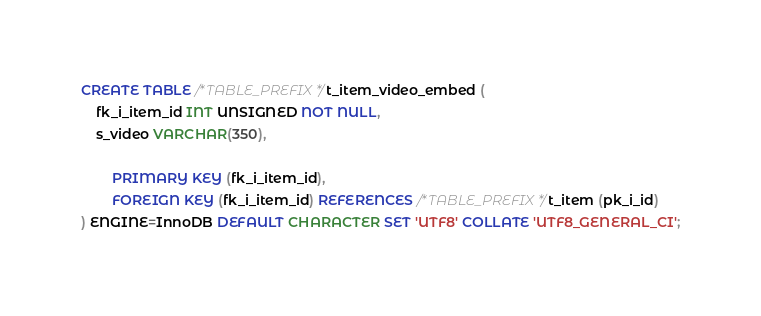<code> <loc_0><loc_0><loc_500><loc_500><_SQL_>CREATE TABLE /*TABLE_PREFIX*/t_item_video_embed (
    fk_i_item_id INT UNSIGNED NOT NULL,
    s_video VARCHAR(350),

        PRIMARY KEY (fk_i_item_id),
        FOREIGN KEY (fk_i_item_id) REFERENCES /*TABLE_PREFIX*/t_item (pk_i_id)
) ENGINE=InnoDB DEFAULT CHARACTER SET 'UTF8' COLLATE 'UTF8_GENERAL_CI';</code> 